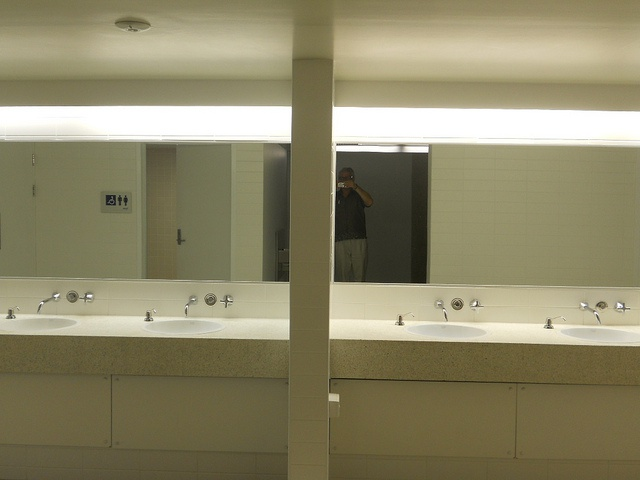Describe the objects in this image and their specific colors. I can see people in olive, black, and gray tones, sink in olive, lightgray, darkgray, beige, and tan tones, sink in olive, lightgray, beige, darkgray, and tan tones, sink in olive, lightgray, beige, and darkgray tones, and sink in olive, lightgray, and darkgray tones in this image. 